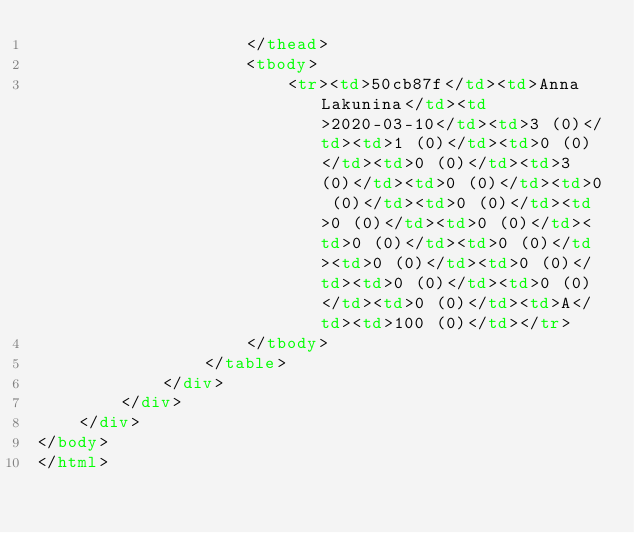<code> <loc_0><loc_0><loc_500><loc_500><_HTML_>                    </thead>
                    <tbody>
                        <tr><td>50cb87f</td><td>Anna Lakunina</td><td>2020-03-10</td><td>3 (0)</td><td>1 (0)</td><td>0 (0)</td><td>0 (0)</td><td>3 (0)</td><td>0 (0)</td><td>0 (0)</td><td>0 (0)</td><td>0 (0)</td><td>0 (0)</td><td>0 (0)</td><td>0 (0)</td><td>0 (0)</td><td>0 (0)</td><td>0 (0)</td><td>0 (0)</td><td>0 (0)</td><td>A</td><td>100 (0)</td></tr>
                    </tbody>
                </table>
            </div>
        </div>
    </div>
</body>
</html></code> 